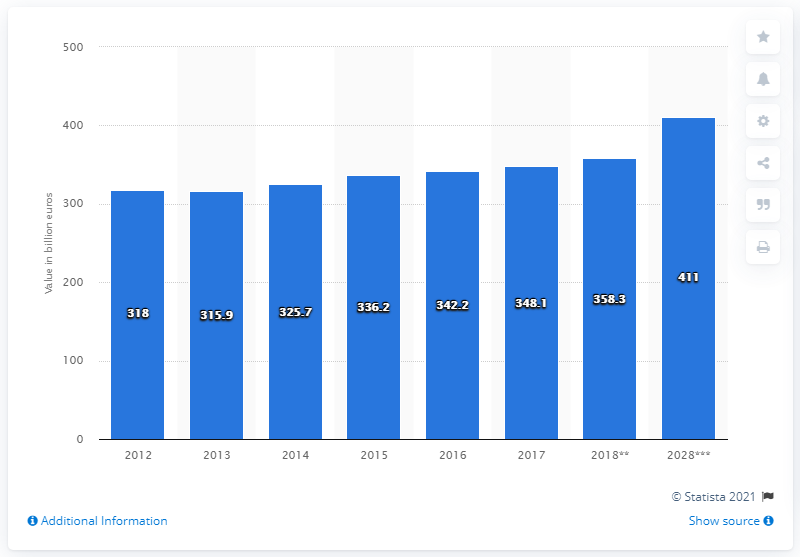Give some essential details in this illustration. The projected contribution of the travel and tourism industry to GDP in Germany in 2018 is 348.1 billion euros. 